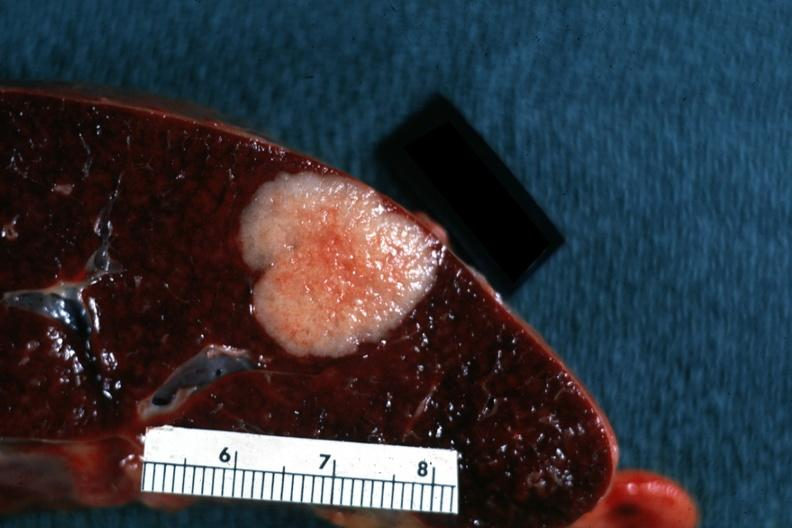what is present?
Answer the question using a single word or phrase. Metastatic carcinoma 